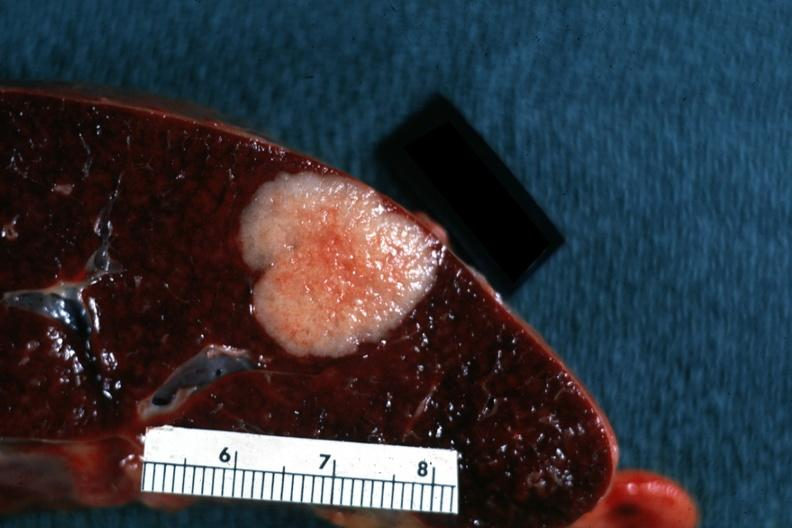what is present?
Answer the question using a single word or phrase. Metastatic carcinoma 